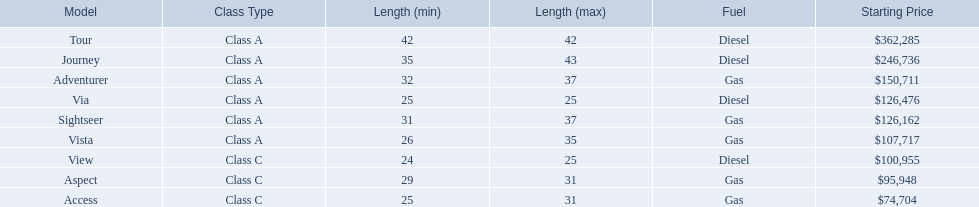Which model has the lowest starting price? Access. Which model has the second most highest starting price? Journey. Which model has the highest price in the winnebago industry? Tour. 